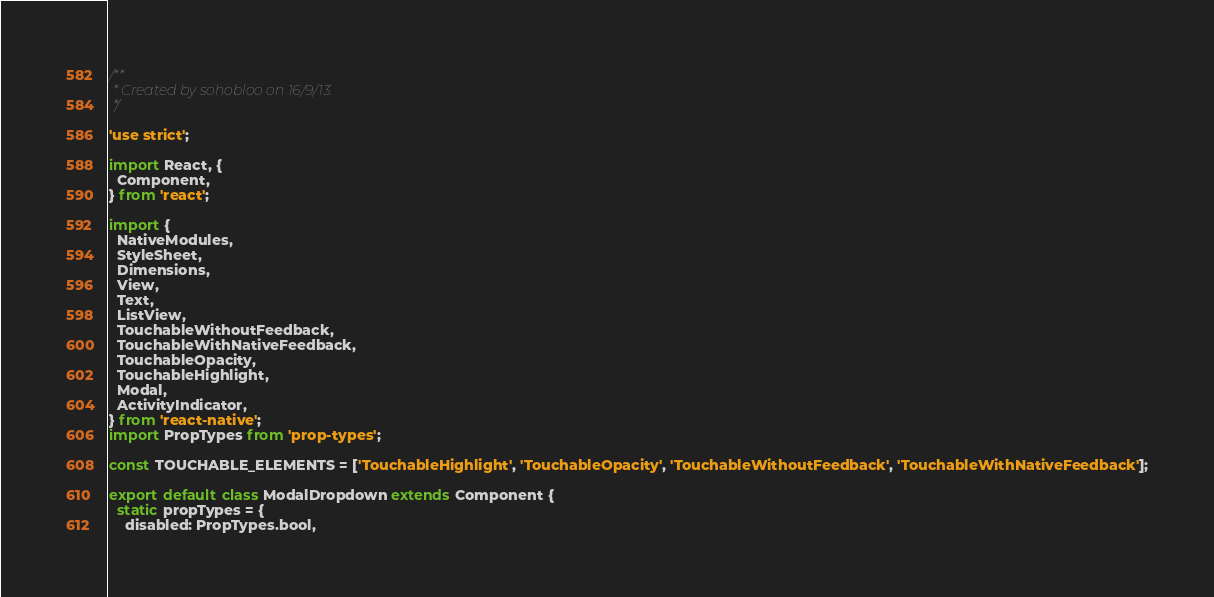<code> <loc_0><loc_0><loc_500><loc_500><_JavaScript_>/**
 * Created by sohobloo on 16/9/13.
 */

'use strict';

import React, {
  Component,
} from 'react';

import {
  NativeModules,
  StyleSheet,
  Dimensions,
  View,
  Text,
  ListView,
  TouchableWithoutFeedback,
  TouchableWithNativeFeedback,
  TouchableOpacity,
  TouchableHighlight,
  Modal,
  ActivityIndicator,
} from 'react-native';
import PropTypes from 'prop-types';

const TOUCHABLE_ELEMENTS = ['TouchableHighlight', 'TouchableOpacity', 'TouchableWithoutFeedback', 'TouchableWithNativeFeedback'];

export default class ModalDropdown extends Component {
  static propTypes = {
    disabled: PropTypes.bool,</code> 